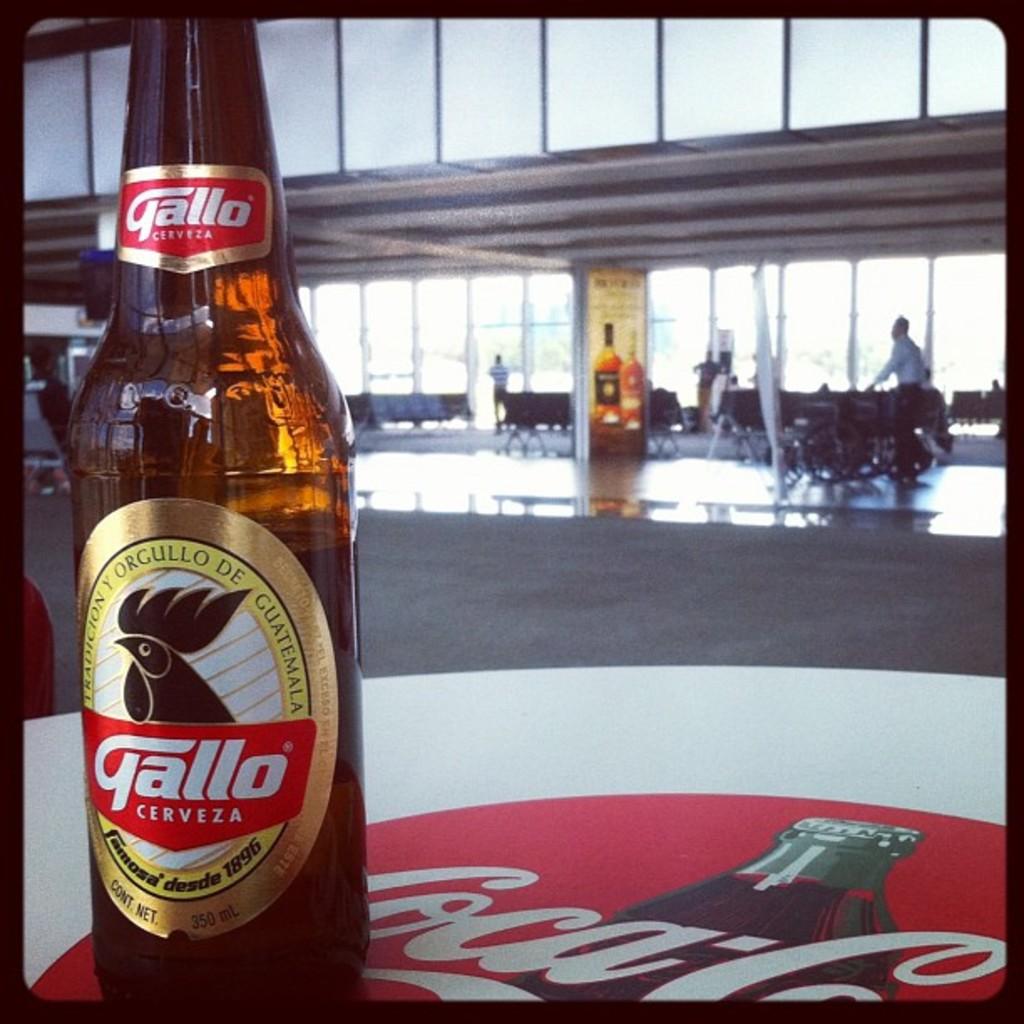Is this a bottle of gallo?
Offer a very short reply. Yes. What brand is this drink?
Your answer should be compact. Gallo. 